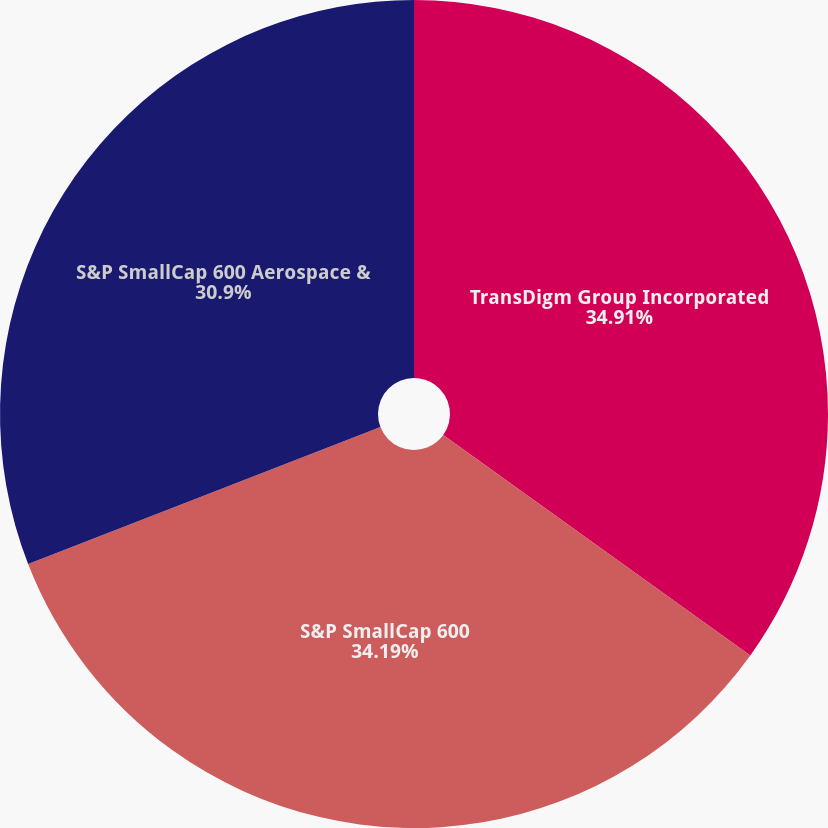Convert chart. <chart><loc_0><loc_0><loc_500><loc_500><pie_chart><fcel>TransDigm Group Incorporated<fcel>S&P SmallCap 600<fcel>S&P SmallCap 600 Aerospace &<nl><fcel>34.91%<fcel>34.19%<fcel>30.9%<nl></chart> 